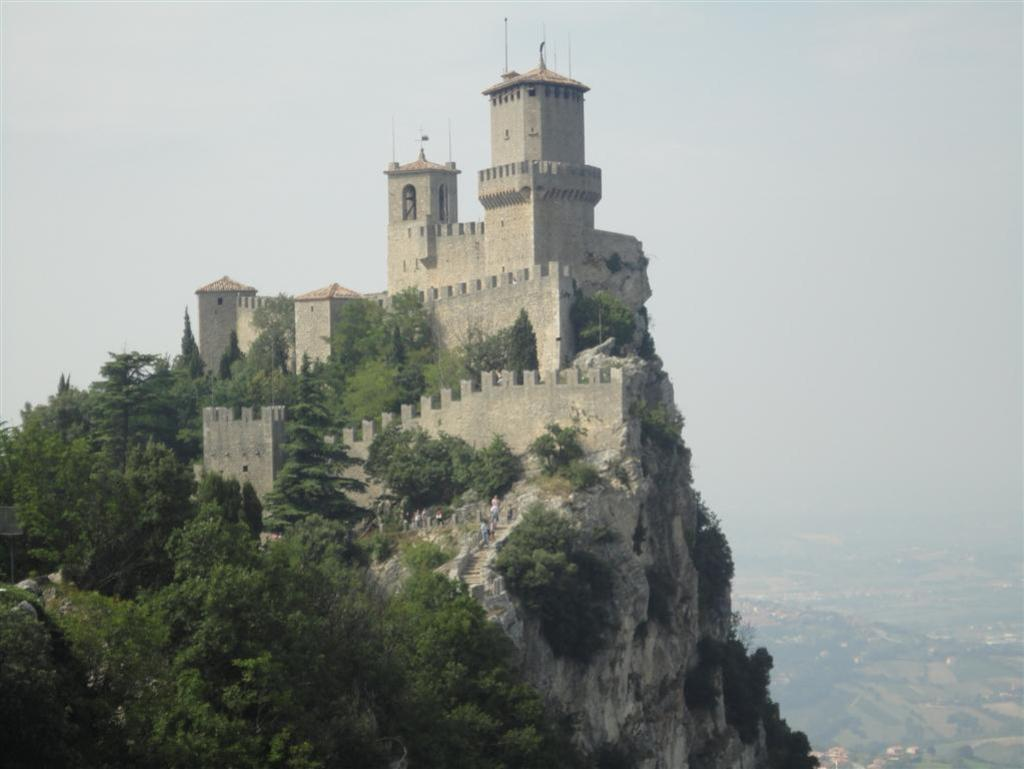Where was the image taken? The image was clicked outside the city. What can be seen in the foreground of the image? There are plants and trees in the foreground of the image, as well as a castle. What is visible in the background of the image? There is a sky visible in the background of the image, along with other objects. What type of scent can be detected from the plants in the image? There is no information about the scent of the plants in the image, so it cannot be determined. 